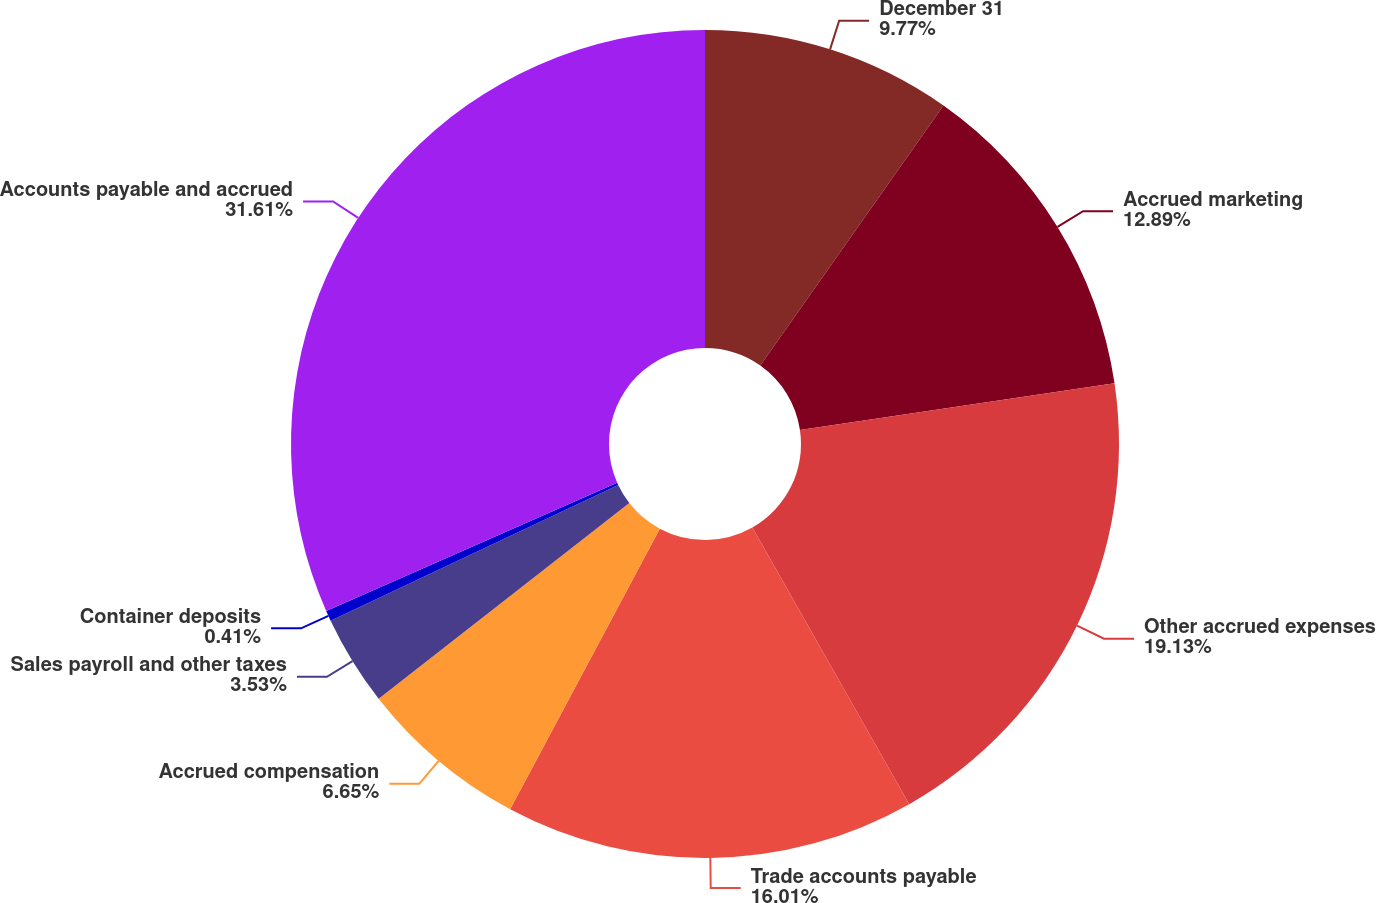<chart> <loc_0><loc_0><loc_500><loc_500><pie_chart><fcel>December 31<fcel>Accrued marketing<fcel>Other accrued expenses<fcel>Trade accounts payable<fcel>Accrued compensation<fcel>Sales payroll and other taxes<fcel>Container deposits<fcel>Accounts payable and accrued<nl><fcel>9.77%<fcel>12.89%<fcel>19.13%<fcel>16.01%<fcel>6.65%<fcel>3.53%<fcel>0.41%<fcel>31.61%<nl></chart> 